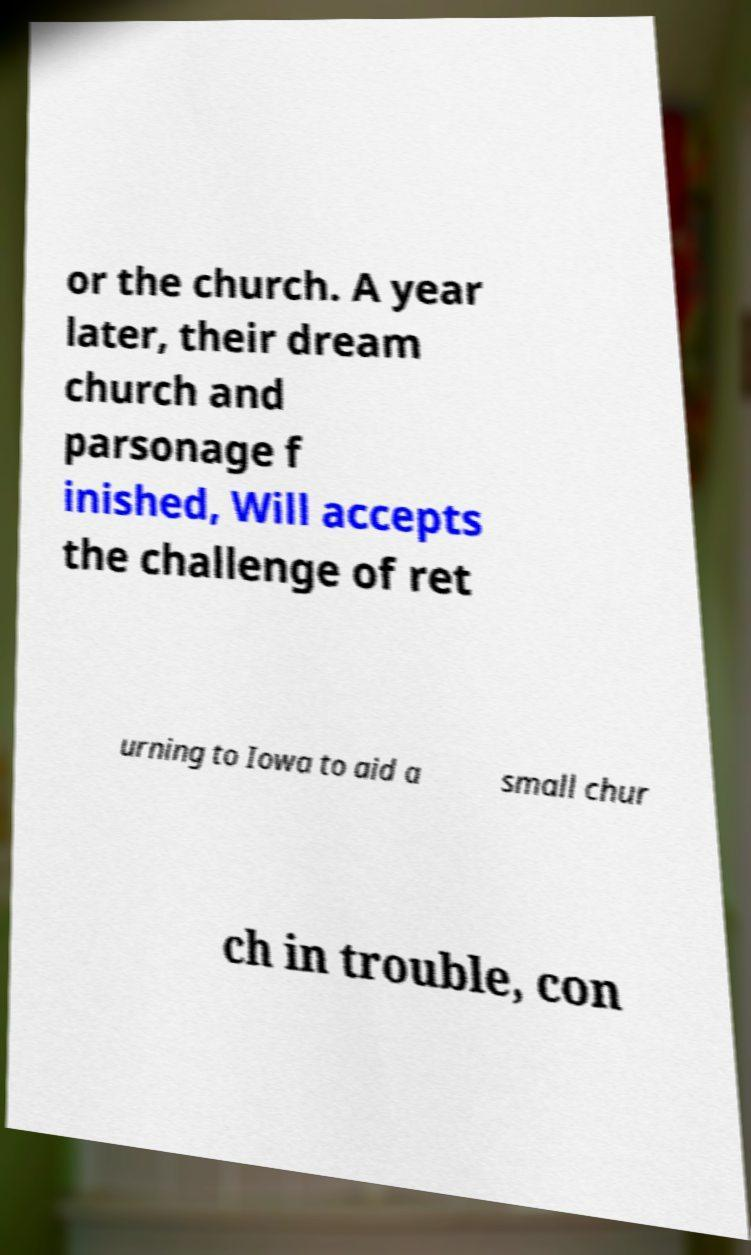Can you read and provide the text displayed in the image?This photo seems to have some interesting text. Can you extract and type it out for me? or the church. A year later, their dream church and parsonage f inished, Will accepts the challenge of ret urning to Iowa to aid a small chur ch in trouble, con 